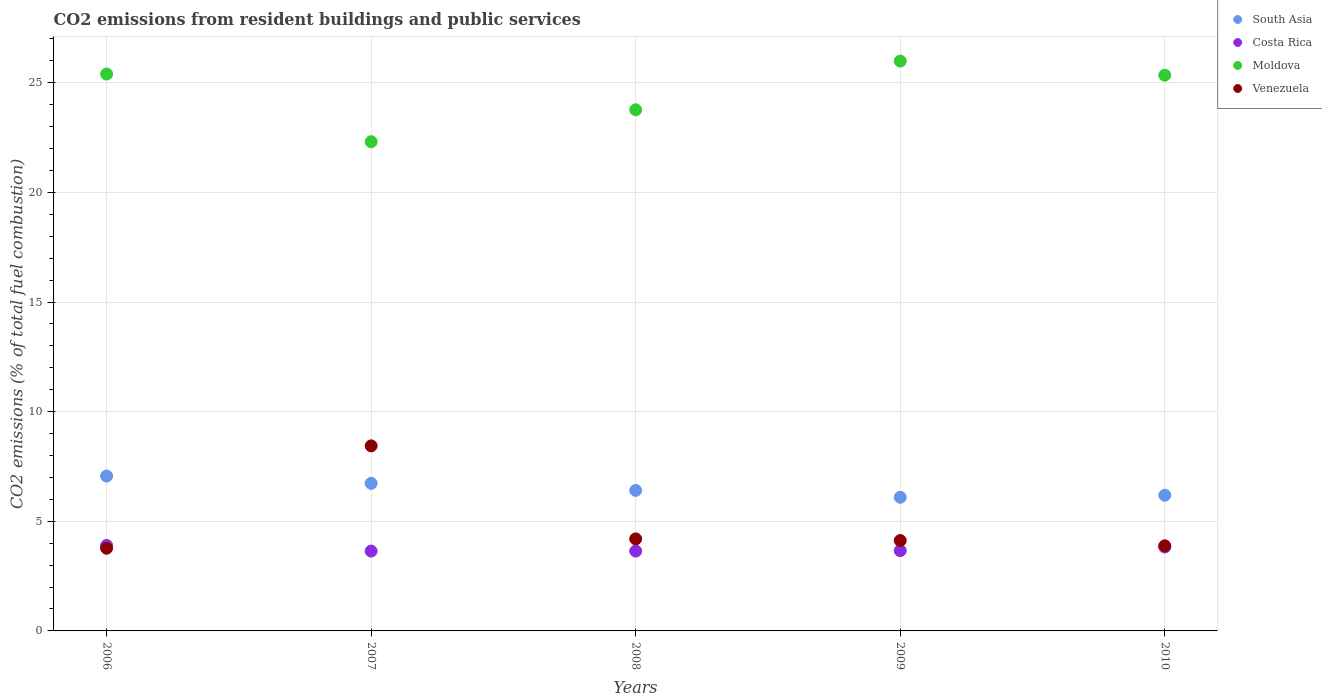How many different coloured dotlines are there?
Your response must be concise. 4. Is the number of dotlines equal to the number of legend labels?
Your answer should be compact. Yes. What is the total CO2 emitted in Venezuela in 2007?
Provide a short and direct response. 8.44. Across all years, what is the maximum total CO2 emitted in Costa Rica?
Give a very brief answer. 3.9. Across all years, what is the minimum total CO2 emitted in Moldova?
Offer a terse response. 22.31. In which year was the total CO2 emitted in South Asia maximum?
Give a very brief answer. 2006. What is the total total CO2 emitted in Moldova in the graph?
Your answer should be very brief. 122.82. What is the difference between the total CO2 emitted in Venezuela in 2008 and that in 2010?
Your answer should be very brief. 0.32. What is the difference between the total CO2 emitted in Costa Rica in 2006 and the total CO2 emitted in Venezuela in 2007?
Ensure brevity in your answer.  -4.54. What is the average total CO2 emitted in South Asia per year?
Make the answer very short. 6.5. In the year 2008, what is the difference between the total CO2 emitted in Moldova and total CO2 emitted in Venezuela?
Your answer should be very brief. 19.57. What is the ratio of the total CO2 emitted in Venezuela in 2007 to that in 2010?
Offer a very short reply. 2.17. Is the total CO2 emitted in Costa Rica in 2008 less than that in 2009?
Make the answer very short. Yes. What is the difference between the highest and the second highest total CO2 emitted in Moldova?
Provide a succinct answer. 0.59. What is the difference between the highest and the lowest total CO2 emitted in Moldova?
Provide a succinct answer. 3.68. In how many years, is the total CO2 emitted in South Asia greater than the average total CO2 emitted in South Asia taken over all years?
Offer a terse response. 2. Is the sum of the total CO2 emitted in Venezuela in 2006 and 2008 greater than the maximum total CO2 emitted in South Asia across all years?
Keep it short and to the point. Yes. Does the total CO2 emitted in Moldova monotonically increase over the years?
Offer a terse response. No. Is the total CO2 emitted in Moldova strictly less than the total CO2 emitted in Costa Rica over the years?
Keep it short and to the point. No. How many dotlines are there?
Give a very brief answer. 4. How many years are there in the graph?
Ensure brevity in your answer.  5. Does the graph contain any zero values?
Provide a succinct answer. No. Where does the legend appear in the graph?
Your answer should be compact. Top right. How many legend labels are there?
Provide a short and direct response. 4. How are the legend labels stacked?
Ensure brevity in your answer.  Vertical. What is the title of the graph?
Offer a terse response. CO2 emissions from resident buildings and public services. What is the label or title of the X-axis?
Your answer should be compact. Years. What is the label or title of the Y-axis?
Keep it short and to the point. CO2 emissions (% of total fuel combustion). What is the CO2 emissions (% of total fuel combustion) of South Asia in 2006?
Provide a succinct answer. 7.06. What is the CO2 emissions (% of total fuel combustion) of Costa Rica in 2006?
Offer a terse response. 3.9. What is the CO2 emissions (% of total fuel combustion) of Moldova in 2006?
Offer a terse response. 25.4. What is the CO2 emissions (% of total fuel combustion) in Venezuela in 2006?
Your response must be concise. 3.77. What is the CO2 emissions (% of total fuel combustion) of South Asia in 2007?
Make the answer very short. 6.73. What is the CO2 emissions (% of total fuel combustion) in Costa Rica in 2007?
Offer a very short reply. 3.64. What is the CO2 emissions (% of total fuel combustion) in Moldova in 2007?
Your answer should be very brief. 22.31. What is the CO2 emissions (% of total fuel combustion) in Venezuela in 2007?
Give a very brief answer. 8.44. What is the CO2 emissions (% of total fuel combustion) of South Asia in 2008?
Keep it short and to the point. 6.41. What is the CO2 emissions (% of total fuel combustion) in Costa Rica in 2008?
Provide a short and direct response. 3.64. What is the CO2 emissions (% of total fuel combustion) of Moldova in 2008?
Ensure brevity in your answer.  23.77. What is the CO2 emissions (% of total fuel combustion) in Venezuela in 2008?
Give a very brief answer. 4.2. What is the CO2 emissions (% of total fuel combustion) in South Asia in 2009?
Offer a terse response. 6.1. What is the CO2 emissions (% of total fuel combustion) in Costa Rica in 2009?
Provide a short and direct response. 3.66. What is the CO2 emissions (% of total fuel combustion) of Moldova in 2009?
Your answer should be compact. 25.99. What is the CO2 emissions (% of total fuel combustion) in Venezuela in 2009?
Provide a succinct answer. 4.12. What is the CO2 emissions (% of total fuel combustion) in South Asia in 2010?
Provide a succinct answer. 6.19. What is the CO2 emissions (% of total fuel combustion) of Costa Rica in 2010?
Ensure brevity in your answer.  3.83. What is the CO2 emissions (% of total fuel combustion) in Moldova in 2010?
Offer a very short reply. 25.35. What is the CO2 emissions (% of total fuel combustion) of Venezuela in 2010?
Your answer should be compact. 3.88. Across all years, what is the maximum CO2 emissions (% of total fuel combustion) of South Asia?
Offer a terse response. 7.06. Across all years, what is the maximum CO2 emissions (% of total fuel combustion) in Costa Rica?
Your response must be concise. 3.9. Across all years, what is the maximum CO2 emissions (% of total fuel combustion) of Moldova?
Make the answer very short. 25.99. Across all years, what is the maximum CO2 emissions (% of total fuel combustion) in Venezuela?
Offer a very short reply. 8.44. Across all years, what is the minimum CO2 emissions (% of total fuel combustion) of South Asia?
Give a very brief answer. 6.1. Across all years, what is the minimum CO2 emissions (% of total fuel combustion) in Costa Rica?
Provide a succinct answer. 3.64. Across all years, what is the minimum CO2 emissions (% of total fuel combustion) of Moldova?
Provide a succinct answer. 22.31. Across all years, what is the minimum CO2 emissions (% of total fuel combustion) in Venezuela?
Your answer should be very brief. 3.77. What is the total CO2 emissions (% of total fuel combustion) in South Asia in the graph?
Offer a very short reply. 32.49. What is the total CO2 emissions (% of total fuel combustion) of Costa Rica in the graph?
Provide a short and direct response. 18.67. What is the total CO2 emissions (% of total fuel combustion) in Moldova in the graph?
Provide a short and direct response. 122.82. What is the total CO2 emissions (% of total fuel combustion) of Venezuela in the graph?
Provide a succinct answer. 24.42. What is the difference between the CO2 emissions (% of total fuel combustion) of South Asia in 2006 and that in 2007?
Make the answer very short. 0.33. What is the difference between the CO2 emissions (% of total fuel combustion) of Costa Rica in 2006 and that in 2007?
Your answer should be compact. 0.26. What is the difference between the CO2 emissions (% of total fuel combustion) in Moldova in 2006 and that in 2007?
Offer a very short reply. 3.09. What is the difference between the CO2 emissions (% of total fuel combustion) of Venezuela in 2006 and that in 2007?
Offer a terse response. -4.67. What is the difference between the CO2 emissions (% of total fuel combustion) in South Asia in 2006 and that in 2008?
Keep it short and to the point. 0.65. What is the difference between the CO2 emissions (% of total fuel combustion) of Costa Rica in 2006 and that in 2008?
Ensure brevity in your answer.  0.26. What is the difference between the CO2 emissions (% of total fuel combustion) in Moldova in 2006 and that in 2008?
Your response must be concise. 1.63. What is the difference between the CO2 emissions (% of total fuel combustion) in Venezuela in 2006 and that in 2008?
Make the answer very short. -0.43. What is the difference between the CO2 emissions (% of total fuel combustion) of South Asia in 2006 and that in 2009?
Your response must be concise. 0.97. What is the difference between the CO2 emissions (% of total fuel combustion) of Costa Rica in 2006 and that in 2009?
Offer a very short reply. 0.24. What is the difference between the CO2 emissions (% of total fuel combustion) in Moldova in 2006 and that in 2009?
Your response must be concise. -0.59. What is the difference between the CO2 emissions (% of total fuel combustion) of Venezuela in 2006 and that in 2009?
Provide a succinct answer. -0.35. What is the difference between the CO2 emissions (% of total fuel combustion) of South Asia in 2006 and that in 2010?
Ensure brevity in your answer.  0.87. What is the difference between the CO2 emissions (% of total fuel combustion) of Costa Rica in 2006 and that in 2010?
Keep it short and to the point. 0.07. What is the difference between the CO2 emissions (% of total fuel combustion) of Moldova in 2006 and that in 2010?
Your response must be concise. 0.05. What is the difference between the CO2 emissions (% of total fuel combustion) in Venezuela in 2006 and that in 2010?
Ensure brevity in your answer.  -0.11. What is the difference between the CO2 emissions (% of total fuel combustion) of South Asia in 2007 and that in 2008?
Your answer should be compact. 0.32. What is the difference between the CO2 emissions (% of total fuel combustion) of Costa Rica in 2007 and that in 2008?
Your answer should be compact. 0. What is the difference between the CO2 emissions (% of total fuel combustion) of Moldova in 2007 and that in 2008?
Ensure brevity in your answer.  -1.46. What is the difference between the CO2 emissions (% of total fuel combustion) of Venezuela in 2007 and that in 2008?
Your answer should be compact. 4.24. What is the difference between the CO2 emissions (% of total fuel combustion) in South Asia in 2007 and that in 2009?
Give a very brief answer. 0.64. What is the difference between the CO2 emissions (% of total fuel combustion) of Costa Rica in 2007 and that in 2009?
Your answer should be compact. -0.02. What is the difference between the CO2 emissions (% of total fuel combustion) of Moldova in 2007 and that in 2009?
Give a very brief answer. -3.68. What is the difference between the CO2 emissions (% of total fuel combustion) of Venezuela in 2007 and that in 2009?
Keep it short and to the point. 4.32. What is the difference between the CO2 emissions (% of total fuel combustion) of South Asia in 2007 and that in 2010?
Provide a succinct answer. 0.54. What is the difference between the CO2 emissions (% of total fuel combustion) in Costa Rica in 2007 and that in 2010?
Provide a succinct answer. -0.19. What is the difference between the CO2 emissions (% of total fuel combustion) of Moldova in 2007 and that in 2010?
Offer a very short reply. -3.04. What is the difference between the CO2 emissions (% of total fuel combustion) of Venezuela in 2007 and that in 2010?
Keep it short and to the point. 4.56. What is the difference between the CO2 emissions (% of total fuel combustion) in South Asia in 2008 and that in 2009?
Ensure brevity in your answer.  0.31. What is the difference between the CO2 emissions (% of total fuel combustion) of Costa Rica in 2008 and that in 2009?
Your answer should be very brief. -0.02. What is the difference between the CO2 emissions (% of total fuel combustion) of Moldova in 2008 and that in 2009?
Provide a succinct answer. -2.22. What is the difference between the CO2 emissions (% of total fuel combustion) in Venezuela in 2008 and that in 2009?
Your response must be concise. 0.08. What is the difference between the CO2 emissions (% of total fuel combustion) of South Asia in 2008 and that in 2010?
Make the answer very short. 0.22. What is the difference between the CO2 emissions (% of total fuel combustion) in Costa Rica in 2008 and that in 2010?
Offer a terse response. -0.19. What is the difference between the CO2 emissions (% of total fuel combustion) in Moldova in 2008 and that in 2010?
Offer a very short reply. -1.58. What is the difference between the CO2 emissions (% of total fuel combustion) in Venezuela in 2008 and that in 2010?
Make the answer very short. 0.32. What is the difference between the CO2 emissions (% of total fuel combustion) in South Asia in 2009 and that in 2010?
Your answer should be very brief. -0.09. What is the difference between the CO2 emissions (% of total fuel combustion) in Costa Rica in 2009 and that in 2010?
Give a very brief answer. -0.17. What is the difference between the CO2 emissions (% of total fuel combustion) of Moldova in 2009 and that in 2010?
Make the answer very short. 0.64. What is the difference between the CO2 emissions (% of total fuel combustion) of Venezuela in 2009 and that in 2010?
Provide a succinct answer. 0.24. What is the difference between the CO2 emissions (% of total fuel combustion) of South Asia in 2006 and the CO2 emissions (% of total fuel combustion) of Costa Rica in 2007?
Offer a terse response. 3.42. What is the difference between the CO2 emissions (% of total fuel combustion) of South Asia in 2006 and the CO2 emissions (% of total fuel combustion) of Moldova in 2007?
Your response must be concise. -15.25. What is the difference between the CO2 emissions (% of total fuel combustion) of South Asia in 2006 and the CO2 emissions (% of total fuel combustion) of Venezuela in 2007?
Your answer should be compact. -1.38. What is the difference between the CO2 emissions (% of total fuel combustion) of Costa Rica in 2006 and the CO2 emissions (% of total fuel combustion) of Moldova in 2007?
Keep it short and to the point. -18.41. What is the difference between the CO2 emissions (% of total fuel combustion) of Costa Rica in 2006 and the CO2 emissions (% of total fuel combustion) of Venezuela in 2007?
Ensure brevity in your answer.  -4.54. What is the difference between the CO2 emissions (% of total fuel combustion) of Moldova in 2006 and the CO2 emissions (% of total fuel combustion) of Venezuela in 2007?
Provide a succinct answer. 16.96. What is the difference between the CO2 emissions (% of total fuel combustion) of South Asia in 2006 and the CO2 emissions (% of total fuel combustion) of Costa Rica in 2008?
Your answer should be very brief. 3.42. What is the difference between the CO2 emissions (% of total fuel combustion) of South Asia in 2006 and the CO2 emissions (% of total fuel combustion) of Moldova in 2008?
Your answer should be very brief. -16.71. What is the difference between the CO2 emissions (% of total fuel combustion) of South Asia in 2006 and the CO2 emissions (% of total fuel combustion) of Venezuela in 2008?
Provide a succinct answer. 2.87. What is the difference between the CO2 emissions (% of total fuel combustion) of Costa Rica in 2006 and the CO2 emissions (% of total fuel combustion) of Moldova in 2008?
Offer a very short reply. -19.87. What is the difference between the CO2 emissions (% of total fuel combustion) of Costa Rica in 2006 and the CO2 emissions (% of total fuel combustion) of Venezuela in 2008?
Provide a succinct answer. -0.3. What is the difference between the CO2 emissions (% of total fuel combustion) in Moldova in 2006 and the CO2 emissions (% of total fuel combustion) in Venezuela in 2008?
Keep it short and to the point. 21.2. What is the difference between the CO2 emissions (% of total fuel combustion) of South Asia in 2006 and the CO2 emissions (% of total fuel combustion) of Costa Rica in 2009?
Provide a succinct answer. 3.4. What is the difference between the CO2 emissions (% of total fuel combustion) in South Asia in 2006 and the CO2 emissions (% of total fuel combustion) in Moldova in 2009?
Provide a succinct answer. -18.93. What is the difference between the CO2 emissions (% of total fuel combustion) of South Asia in 2006 and the CO2 emissions (% of total fuel combustion) of Venezuela in 2009?
Your answer should be compact. 2.94. What is the difference between the CO2 emissions (% of total fuel combustion) in Costa Rica in 2006 and the CO2 emissions (% of total fuel combustion) in Moldova in 2009?
Keep it short and to the point. -22.09. What is the difference between the CO2 emissions (% of total fuel combustion) in Costa Rica in 2006 and the CO2 emissions (% of total fuel combustion) in Venezuela in 2009?
Provide a short and direct response. -0.22. What is the difference between the CO2 emissions (% of total fuel combustion) in Moldova in 2006 and the CO2 emissions (% of total fuel combustion) in Venezuela in 2009?
Give a very brief answer. 21.28. What is the difference between the CO2 emissions (% of total fuel combustion) of South Asia in 2006 and the CO2 emissions (% of total fuel combustion) of Costa Rica in 2010?
Offer a very short reply. 3.24. What is the difference between the CO2 emissions (% of total fuel combustion) in South Asia in 2006 and the CO2 emissions (% of total fuel combustion) in Moldova in 2010?
Ensure brevity in your answer.  -18.28. What is the difference between the CO2 emissions (% of total fuel combustion) of South Asia in 2006 and the CO2 emissions (% of total fuel combustion) of Venezuela in 2010?
Ensure brevity in your answer.  3.18. What is the difference between the CO2 emissions (% of total fuel combustion) of Costa Rica in 2006 and the CO2 emissions (% of total fuel combustion) of Moldova in 2010?
Offer a very short reply. -21.45. What is the difference between the CO2 emissions (% of total fuel combustion) of Costa Rica in 2006 and the CO2 emissions (% of total fuel combustion) of Venezuela in 2010?
Offer a very short reply. 0.02. What is the difference between the CO2 emissions (% of total fuel combustion) of Moldova in 2006 and the CO2 emissions (% of total fuel combustion) of Venezuela in 2010?
Your answer should be compact. 21.52. What is the difference between the CO2 emissions (% of total fuel combustion) of South Asia in 2007 and the CO2 emissions (% of total fuel combustion) of Costa Rica in 2008?
Provide a short and direct response. 3.09. What is the difference between the CO2 emissions (% of total fuel combustion) in South Asia in 2007 and the CO2 emissions (% of total fuel combustion) in Moldova in 2008?
Make the answer very short. -17.04. What is the difference between the CO2 emissions (% of total fuel combustion) of South Asia in 2007 and the CO2 emissions (% of total fuel combustion) of Venezuela in 2008?
Make the answer very short. 2.53. What is the difference between the CO2 emissions (% of total fuel combustion) in Costa Rica in 2007 and the CO2 emissions (% of total fuel combustion) in Moldova in 2008?
Give a very brief answer. -20.13. What is the difference between the CO2 emissions (% of total fuel combustion) in Costa Rica in 2007 and the CO2 emissions (% of total fuel combustion) in Venezuela in 2008?
Keep it short and to the point. -0.56. What is the difference between the CO2 emissions (% of total fuel combustion) in Moldova in 2007 and the CO2 emissions (% of total fuel combustion) in Venezuela in 2008?
Your answer should be very brief. 18.11. What is the difference between the CO2 emissions (% of total fuel combustion) of South Asia in 2007 and the CO2 emissions (% of total fuel combustion) of Costa Rica in 2009?
Ensure brevity in your answer.  3.07. What is the difference between the CO2 emissions (% of total fuel combustion) of South Asia in 2007 and the CO2 emissions (% of total fuel combustion) of Moldova in 2009?
Your answer should be very brief. -19.26. What is the difference between the CO2 emissions (% of total fuel combustion) in South Asia in 2007 and the CO2 emissions (% of total fuel combustion) in Venezuela in 2009?
Keep it short and to the point. 2.61. What is the difference between the CO2 emissions (% of total fuel combustion) in Costa Rica in 2007 and the CO2 emissions (% of total fuel combustion) in Moldova in 2009?
Your answer should be compact. -22.35. What is the difference between the CO2 emissions (% of total fuel combustion) in Costa Rica in 2007 and the CO2 emissions (% of total fuel combustion) in Venezuela in 2009?
Provide a short and direct response. -0.48. What is the difference between the CO2 emissions (% of total fuel combustion) of Moldova in 2007 and the CO2 emissions (% of total fuel combustion) of Venezuela in 2009?
Your response must be concise. 18.19. What is the difference between the CO2 emissions (% of total fuel combustion) in South Asia in 2007 and the CO2 emissions (% of total fuel combustion) in Costa Rica in 2010?
Provide a short and direct response. 2.9. What is the difference between the CO2 emissions (% of total fuel combustion) of South Asia in 2007 and the CO2 emissions (% of total fuel combustion) of Moldova in 2010?
Offer a very short reply. -18.62. What is the difference between the CO2 emissions (% of total fuel combustion) of South Asia in 2007 and the CO2 emissions (% of total fuel combustion) of Venezuela in 2010?
Your answer should be very brief. 2.85. What is the difference between the CO2 emissions (% of total fuel combustion) in Costa Rica in 2007 and the CO2 emissions (% of total fuel combustion) in Moldova in 2010?
Ensure brevity in your answer.  -21.71. What is the difference between the CO2 emissions (% of total fuel combustion) in Costa Rica in 2007 and the CO2 emissions (% of total fuel combustion) in Venezuela in 2010?
Your response must be concise. -0.24. What is the difference between the CO2 emissions (% of total fuel combustion) of Moldova in 2007 and the CO2 emissions (% of total fuel combustion) of Venezuela in 2010?
Provide a short and direct response. 18.43. What is the difference between the CO2 emissions (% of total fuel combustion) of South Asia in 2008 and the CO2 emissions (% of total fuel combustion) of Costa Rica in 2009?
Your response must be concise. 2.75. What is the difference between the CO2 emissions (% of total fuel combustion) in South Asia in 2008 and the CO2 emissions (% of total fuel combustion) in Moldova in 2009?
Offer a very short reply. -19.58. What is the difference between the CO2 emissions (% of total fuel combustion) of South Asia in 2008 and the CO2 emissions (% of total fuel combustion) of Venezuela in 2009?
Provide a short and direct response. 2.29. What is the difference between the CO2 emissions (% of total fuel combustion) in Costa Rica in 2008 and the CO2 emissions (% of total fuel combustion) in Moldova in 2009?
Your answer should be very brief. -22.35. What is the difference between the CO2 emissions (% of total fuel combustion) of Costa Rica in 2008 and the CO2 emissions (% of total fuel combustion) of Venezuela in 2009?
Your response must be concise. -0.48. What is the difference between the CO2 emissions (% of total fuel combustion) in Moldova in 2008 and the CO2 emissions (% of total fuel combustion) in Venezuela in 2009?
Your answer should be very brief. 19.65. What is the difference between the CO2 emissions (% of total fuel combustion) of South Asia in 2008 and the CO2 emissions (% of total fuel combustion) of Costa Rica in 2010?
Your answer should be compact. 2.58. What is the difference between the CO2 emissions (% of total fuel combustion) in South Asia in 2008 and the CO2 emissions (% of total fuel combustion) in Moldova in 2010?
Your answer should be very brief. -18.94. What is the difference between the CO2 emissions (% of total fuel combustion) of South Asia in 2008 and the CO2 emissions (% of total fuel combustion) of Venezuela in 2010?
Offer a very short reply. 2.53. What is the difference between the CO2 emissions (% of total fuel combustion) in Costa Rica in 2008 and the CO2 emissions (% of total fuel combustion) in Moldova in 2010?
Provide a succinct answer. -21.71. What is the difference between the CO2 emissions (% of total fuel combustion) of Costa Rica in 2008 and the CO2 emissions (% of total fuel combustion) of Venezuela in 2010?
Make the answer very short. -0.24. What is the difference between the CO2 emissions (% of total fuel combustion) in Moldova in 2008 and the CO2 emissions (% of total fuel combustion) in Venezuela in 2010?
Ensure brevity in your answer.  19.89. What is the difference between the CO2 emissions (% of total fuel combustion) in South Asia in 2009 and the CO2 emissions (% of total fuel combustion) in Costa Rica in 2010?
Provide a succinct answer. 2.27. What is the difference between the CO2 emissions (% of total fuel combustion) in South Asia in 2009 and the CO2 emissions (% of total fuel combustion) in Moldova in 2010?
Provide a short and direct response. -19.25. What is the difference between the CO2 emissions (% of total fuel combustion) in South Asia in 2009 and the CO2 emissions (% of total fuel combustion) in Venezuela in 2010?
Provide a short and direct response. 2.21. What is the difference between the CO2 emissions (% of total fuel combustion) of Costa Rica in 2009 and the CO2 emissions (% of total fuel combustion) of Moldova in 2010?
Your answer should be very brief. -21.69. What is the difference between the CO2 emissions (% of total fuel combustion) in Costa Rica in 2009 and the CO2 emissions (% of total fuel combustion) in Venezuela in 2010?
Your answer should be very brief. -0.22. What is the difference between the CO2 emissions (% of total fuel combustion) of Moldova in 2009 and the CO2 emissions (% of total fuel combustion) of Venezuela in 2010?
Keep it short and to the point. 22.11. What is the average CO2 emissions (% of total fuel combustion) of South Asia per year?
Your answer should be compact. 6.5. What is the average CO2 emissions (% of total fuel combustion) in Costa Rica per year?
Make the answer very short. 3.73. What is the average CO2 emissions (% of total fuel combustion) of Moldova per year?
Your response must be concise. 24.57. What is the average CO2 emissions (% of total fuel combustion) in Venezuela per year?
Make the answer very short. 4.88. In the year 2006, what is the difference between the CO2 emissions (% of total fuel combustion) of South Asia and CO2 emissions (% of total fuel combustion) of Costa Rica?
Provide a succinct answer. 3.17. In the year 2006, what is the difference between the CO2 emissions (% of total fuel combustion) of South Asia and CO2 emissions (% of total fuel combustion) of Moldova?
Offer a very short reply. -18.34. In the year 2006, what is the difference between the CO2 emissions (% of total fuel combustion) in South Asia and CO2 emissions (% of total fuel combustion) in Venezuela?
Ensure brevity in your answer.  3.29. In the year 2006, what is the difference between the CO2 emissions (% of total fuel combustion) in Costa Rica and CO2 emissions (% of total fuel combustion) in Moldova?
Provide a short and direct response. -21.5. In the year 2006, what is the difference between the CO2 emissions (% of total fuel combustion) in Costa Rica and CO2 emissions (% of total fuel combustion) in Venezuela?
Keep it short and to the point. 0.13. In the year 2006, what is the difference between the CO2 emissions (% of total fuel combustion) in Moldova and CO2 emissions (% of total fuel combustion) in Venezuela?
Provide a short and direct response. 21.63. In the year 2007, what is the difference between the CO2 emissions (% of total fuel combustion) of South Asia and CO2 emissions (% of total fuel combustion) of Costa Rica?
Keep it short and to the point. 3.09. In the year 2007, what is the difference between the CO2 emissions (% of total fuel combustion) of South Asia and CO2 emissions (% of total fuel combustion) of Moldova?
Make the answer very short. -15.58. In the year 2007, what is the difference between the CO2 emissions (% of total fuel combustion) of South Asia and CO2 emissions (% of total fuel combustion) of Venezuela?
Your answer should be very brief. -1.71. In the year 2007, what is the difference between the CO2 emissions (% of total fuel combustion) of Costa Rica and CO2 emissions (% of total fuel combustion) of Moldova?
Provide a short and direct response. -18.67. In the year 2007, what is the difference between the CO2 emissions (% of total fuel combustion) in Costa Rica and CO2 emissions (% of total fuel combustion) in Venezuela?
Your response must be concise. -4.8. In the year 2007, what is the difference between the CO2 emissions (% of total fuel combustion) of Moldova and CO2 emissions (% of total fuel combustion) of Venezuela?
Keep it short and to the point. 13.87. In the year 2008, what is the difference between the CO2 emissions (% of total fuel combustion) in South Asia and CO2 emissions (% of total fuel combustion) in Costa Rica?
Offer a terse response. 2.77. In the year 2008, what is the difference between the CO2 emissions (% of total fuel combustion) of South Asia and CO2 emissions (% of total fuel combustion) of Moldova?
Offer a terse response. -17.36. In the year 2008, what is the difference between the CO2 emissions (% of total fuel combustion) of South Asia and CO2 emissions (% of total fuel combustion) of Venezuela?
Ensure brevity in your answer.  2.21. In the year 2008, what is the difference between the CO2 emissions (% of total fuel combustion) in Costa Rica and CO2 emissions (% of total fuel combustion) in Moldova?
Ensure brevity in your answer.  -20.13. In the year 2008, what is the difference between the CO2 emissions (% of total fuel combustion) of Costa Rica and CO2 emissions (% of total fuel combustion) of Venezuela?
Provide a short and direct response. -0.56. In the year 2008, what is the difference between the CO2 emissions (% of total fuel combustion) in Moldova and CO2 emissions (% of total fuel combustion) in Venezuela?
Keep it short and to the point. 19.57. In the year 2009, what is the difference between the CO2 emissions (% of total fuel combustion) of South Asia and CO2 emissions (% of total fuel combustion) of Costa Rica?
Your answer should be compact. 2.43. In the year 2009, what is the difference between the CO2 emissions (% of total fuel combustion) of South Asia and CO2 emissions (% of total fuel combustion) of Moldova?
Give a very brief answer. -19.9. In the year 2009, what is the difference between the CO2 emissions (% of total fuel combustion) of South Asia and CO2 emissions (% of total fuel combustion) of Venezuela?
Your answer should be compact. 1.97. In the year 2009, what is the difference between the CO2 emissions (% of total fuel combustion) in Costa Rica and CO2 emissions (% of total fuel combustion) in Moldova?
Offer a very short reply. -22.33. In the year 2009, what is the difference between the CO2 emissions (% of total fuel combustion) in Costa Rica and CO2 emissions (% of total fuel combustion) in Venezuela?
Your answer should be compact. -0.46. In the year 2009, what is the difference between the CO2 emissions (% of total fuel combustion) of Moldova and CO2 emissions (% of total fuel combustion) of Venezuela?
Provide a short and direct response. 21.87. In the year 2010, what is the difference between the CO2 emissions (% of total fuel combustion) of South Asia and CO2 emissions (% of total fuel combustion) of Costa Rica?
Make the answer very short. 2.36. In the year 2010, what is the difference between the CO2 emissions (% of total fuel combustion) of South Asia and CO2 emissions (% of total fuel combustion) of Moldova?
Keep it short and to the point. -19.16. In the year 2010, what is the difference between the CO2 emissions (% of total fuel combustion) in South Asia and CO2 emissions (% of total fuel combustion) in Venezuela?
Offer a very short reply. 2.31. In the year 2010, what is the difference between the CO2 emissions (% of total fuel combustion) in Costa Rica and CO2 emissions (% of total fuel combustion) in Moldova?
Provide a succinct answer. -21.52. In the year 2010, what is the difference between the CO2 emissions (% of total fuel combustion) in Costa Rica and CO2 emissions (% of total fuel combustion) in Venezuela?
Your answer should be compact. -0.05. In the year 2010, what is the difference between the CO2 emissions (% of total fuel combustion) of Moldova and CO2 emissions (% of total fuel combustion) of Venezuela?
Provide a short and direct response. 21.47. What is the ratio of the CO2 emissions (% of total fuel combustion) of South Asia in 2006 to that in 2007?
Make the answer very short. 1.05. What is the ratio of the CO2 emissions (% of total fuel combustion) in Costa Rica in 2006 to that in 2007?
Offer a terse response. 1.07. What is the ratio of the CO2 emissions (% of total fuel combustion) in Moldova in 2006 to that in 2007?
Provide a short and direct response. 1.14. What is the ratio of the CO2 emissions (% of total fuel combustion) of Venezuela in 2006 to that in 2007?
Ensure brevity in your answer.  0.45. What is the ratio of the CO2 emissions (% of total fuel combustion) of South Asia in 2006 to that in 2008?
Offer a very short reply. 1.1. What is the ratio of the CO2 emissions (% of total fuel combustion) of Costa Rica in 2006 to that in 2008?
Provide a succinct answer. 1.07. What is the ratio of the CO2 emissions (% of total fuel combustion) in Moldova in 2006 to that in 2008?
Your answer should be compact. 1.07. What is the ratio of the CO2 emissions (% of total fuel combustion) of Venezuela in 2006 to that in 2008?
Ensure brevity in your answer.  0.9. What is the ratio of the CO2 emissions (% of total fuel combustion) in South Asia in 2006 to that in 2009?
Your answer should be very brief. 1.16. What is the ratio of the CO2 emissions (% of total fuel combustion) in Costa Rica in 2006 to that in 2009?
Your answer should be compact. 1.06. What is the ratio of the CO2 emissions (% of total fuel combustion) in Moldova in 2006 to that in 2009?
Offer a terse response. 0.98. What is the ratio of the CO2 emissions (% of total fuel combustion) of Venezuela in 2006 to that in 2009?
Your response must be concise. 0.91. What is the ratio of the CO2 emissions (% of total fuel combustion) in South Asia in 2006 to that in 2010?
Your response must be concise. 1.14. What is the ratio of the CO2 emissions (% of total fuel combustion) in Costa Rica in 2006 to that in 2010?
Offer a terse response. 1.02. What is the ratio of the CO2 emissions (% of total fuel combustion) in Moldova in 2006 to that in 2010?
Provide a succinct answer. 1. What is the ratio of the CO2 emissions (% of total fuel combustion) in Venezuela in 2006 to that in 2010?
Offer a terse response. 0.97. What is the ratio of the CO2 emissions (% of total fuel combustion) in South Asia in 2007 to that in 2008?
Your response must be concise. 1.05. What is the ratio of the CO2 emissions (% of total fuel combustion) of Moldova in 2007 to that in 2008?
Your answer should be very brief. 0.94. What is the ratio of the CO2 emissions (% of total fuel combustion) in Venezuela in 2007 to that in 2008?
Your response must be concise. 2.01. What is the ratio of the CO2 emissions (% of total fuel combustion) of South Asia in 2007 to that in 2009?
Give a very brief answer. 1.1. What is the ratio of the CO2 emissions (% of total fuel combustion) of Costa Rica in 2007 to that in 2009?
Keep it short and to the point. 0.99. What is the ratio of the CO2 emissions (% of total fuel combustion) of Moldova in 2007 to that in 2009?
Your response must be concise. 0.86. What is the ratio of the CO2 emissions (% of total fuel combustion) in Venezuela in 2007 to that in 2009?
Ensure brevity in your answer.  2.05. What is the ratio of the CO2 emissions (% of total fuel combustion) of South Asia in 2007 to that in 2010?
Your answer should be very brief. 1.09. What is the ratio of the CO2 emissions (% of total fuel combustion) of Costa Rica in 2007 to that in 2010?
Give a very brief answer. 0.95. What is the ratio of the CO2 emissions (% of total fuel combustion) in Moldova in 2007 to that in 2010?
Give a very brief answer. 0.88. What is the ratio of the CO2 emissions (% of total fuel combustion) in Venezuela in 2007 to that in 2010?
Provide a succinct answer. 2.17. What is the ratio of the CO2 emissions (% of total fuel combustion) in South Asia in 2008 to that in 2009?
Keep it short and to the point. 1.05. What is the ratio of the CO2 emissions (% of total fuel combustion) in Moldova in 2008 to that in 2009?
Provide a succinct answer. 0.91. What is the ratio of the CO2 emissions (% of total fuel combustion) of Venezuela in 2008 to that in 2009?
Make the answer very short. 1.02. What is the ratio of the CO2 emissions (% of total fuel combustion) in South Asia in 2008 to that in 2010?
Provide a succinct answer. 1.04. What is the ratio of the CO2 emissions (% of total fuel combustion) in Costa Rica in 2008 to that in 2010?
Your response must be concise. 0.95. What is the ratio of the CO2 emissions (% of total fuel combustion) in Moldova in 2008 to that in 2010?
Your answer should be compact. 0.94. What is the ratio of the CO2 emissions (% of total fuel combustion) in Venezuela in 2008 to that in 2010?
Give a very brief answer. 1.08. What is the ratio of the CO2 emissions (% of total fuel combustion) of South Asia in 2009 to that in 2010?
Provide a short and direct response. 0.98. What is the ratio of the CO2 emissions (% of total fuel combustion) in Costa Rica in 2009 to that in 2010?
Provide a succinct answer. 0.96. What is the ratio of the CO2 emissions (% of total fuel combustion) of Moldova in 2009 to that in 2010?
Give a very brief answer. 1.03. What is the ratio of the CO2 emissions (% of total fuel combustion) in Venezuela in 2009 to that in 2010?
Offer a very short reply. 1.06. What is the difference between the highest and the second highest CO2 emissions (% of total fuel combustion) in South Asia?
Offer a terse response. 0.33. What is the difference between the highest and the second highest CO2 emissions (% of total fuel combustion) of Costa Rica?
Ensure brevity in your answer.  0.07. What is the difference between the highest and the second highest CO2 emissions (% of total fuel combustion) of Moldova?
Your response must be concise. 0.59. What is the difference between the highest and the second highest CO2 emissions (% of total fuel combustion) in Venezuela?
Make the answer very short. 4.24. What is the difference between the highest and the lowest CO2 emissions (% of total fuel combustion) of South Asia?
Give a very brief answer. 0.97. What is the difference between the highest and the lowest CO2 emissions (% of total fuel combustion) of Costa Rica?
Your response must be concise. 0.26. What is the difference between the highest and the lowest CO2 emissions (% of total fuel combustion) of Moldova?
Provide a succinct answer. 3.68. What is the difference between the highest and the lowest CO2 emissions (% of total fuel combustion) in Venezuela?
Ensure brevity in your answer.  4.67. 